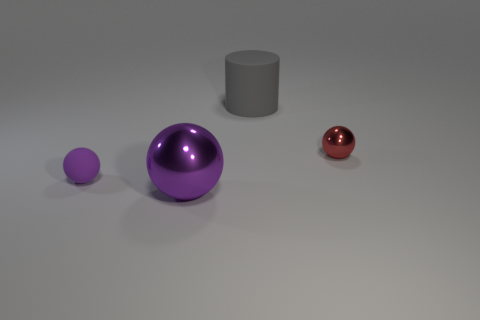Subtract all brown cubes. How many purple spheres are left? 2 Add 1 purple spheres. How many objects exist? 5 Subtract all balls. How many objects are left? 1 Add 2 metal balls. How many metal balls are left? 4 Add 2 small things. How many small things exist? 4 Subtract 0 brown blocks. How many objects are left? 4 Subtract all big gray rubber cylinders. Subtract all shiny things. How many objects are left? 1 